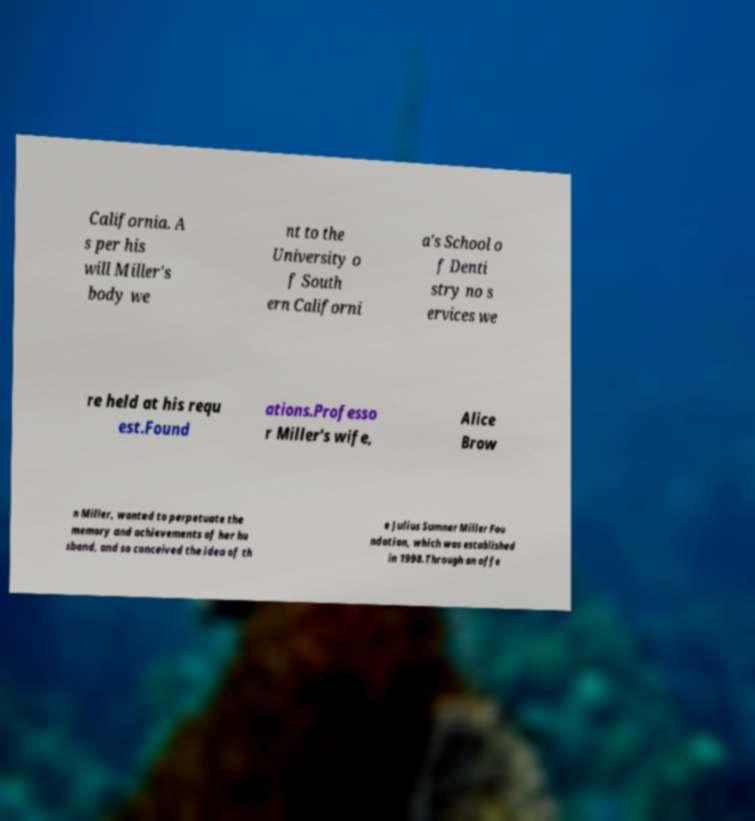Could you assist in decoding the text presented in this image and type it out clearly? California. A s per his will Miller's body we nt to the University o f South ern Californi a's School o f Denti stry no s ervices we re held at his requ est.Found ations.Professo r Miller's wife, Alice Brow n Miller, wanted to perpetuate the memory and achievements of her hu sband, and so conceived the idea of th e Julius Sumner Miller Fou ndation, which was established in 1998.Through an offe 